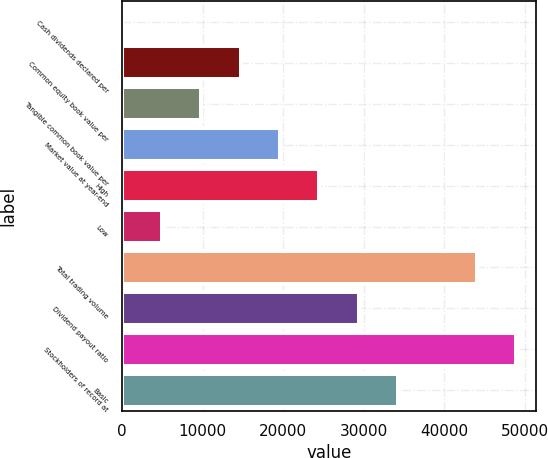Convert chart. <chart><loc_0><loc_0><loc_500><loc_500><bar_chart><fcel>Cash dividends declared per<fcel>Common equity book value per<fcel>Tangible common book value per<fcel>Market value at year-end<fcel>High<fcel>Low<fcel>Total trading volume<fcel>Dividend payout ratio<fcel>Stockholders of record at<fcel>Basic<nl><fcel>0.26<fcel>14687.6<fcel>9791.8<fcel>19583.3<fcel>24479.1<fcel>4896.03<fcel>44062.2<fcel>29374.9<fcel>48958<fcel>34270.7<nl></chart> 